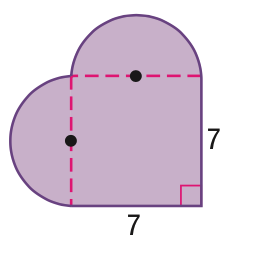Answer the mathemtical geometry problem and directly provide the correct option letter.
Question: Find the area of the figure. Round to the nearest tenth.
Choices: A: 49 B: 68.2 C: 87.5 D: 126.0 C 